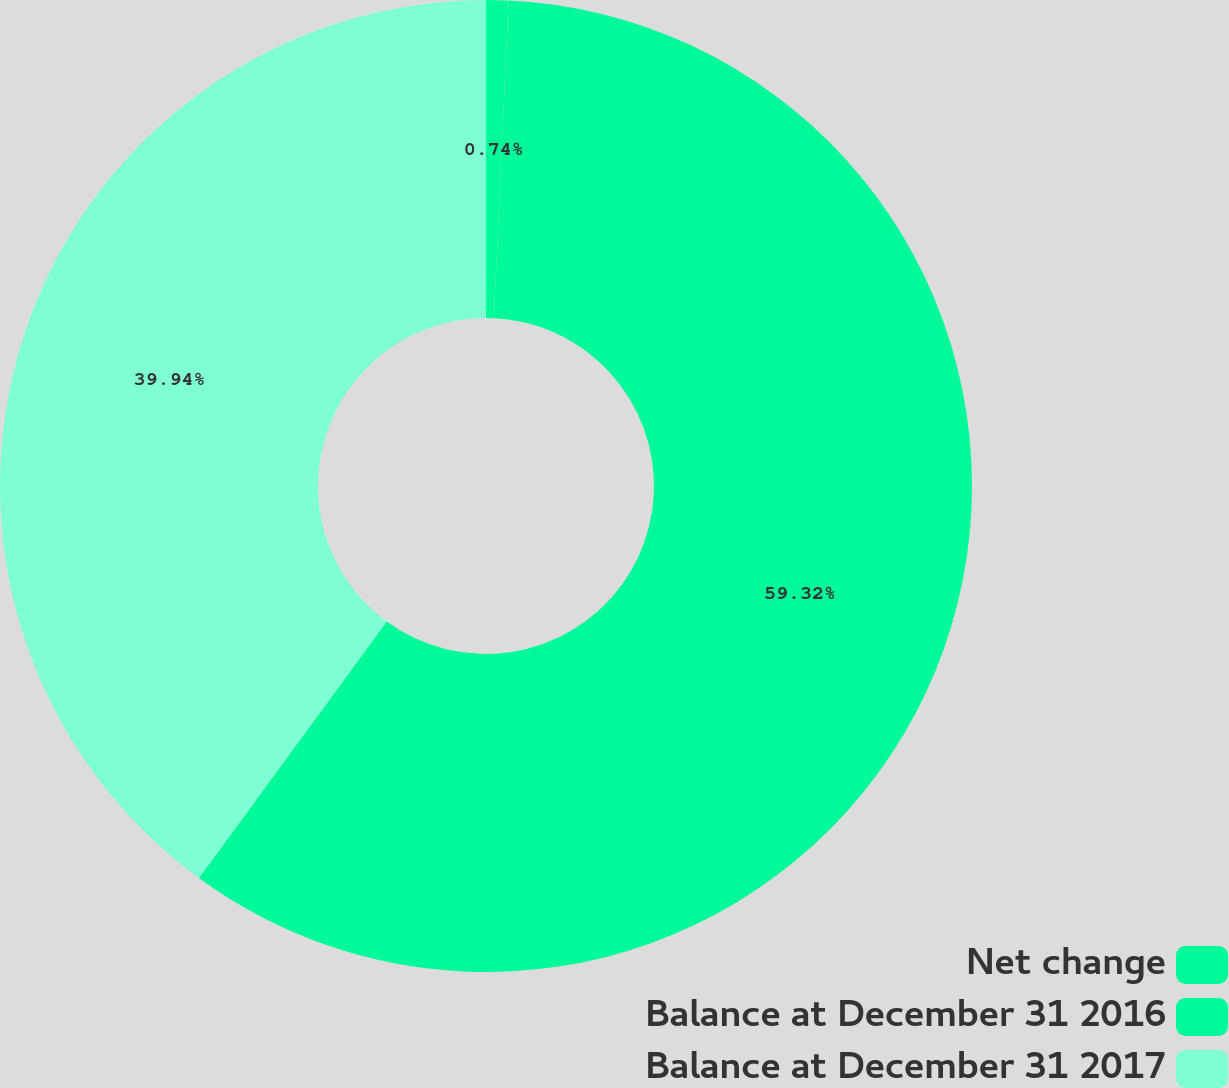<chart> <loc_0><loc_0><loc_500><loc_500><pie_chart><fcel>Net change<fcel>Balance at December 31 2016<fcel>Balance at December 31 2017<nl><fcel>0.74%<fcel>59.32%<fcel>39.94%<nl></chart> 